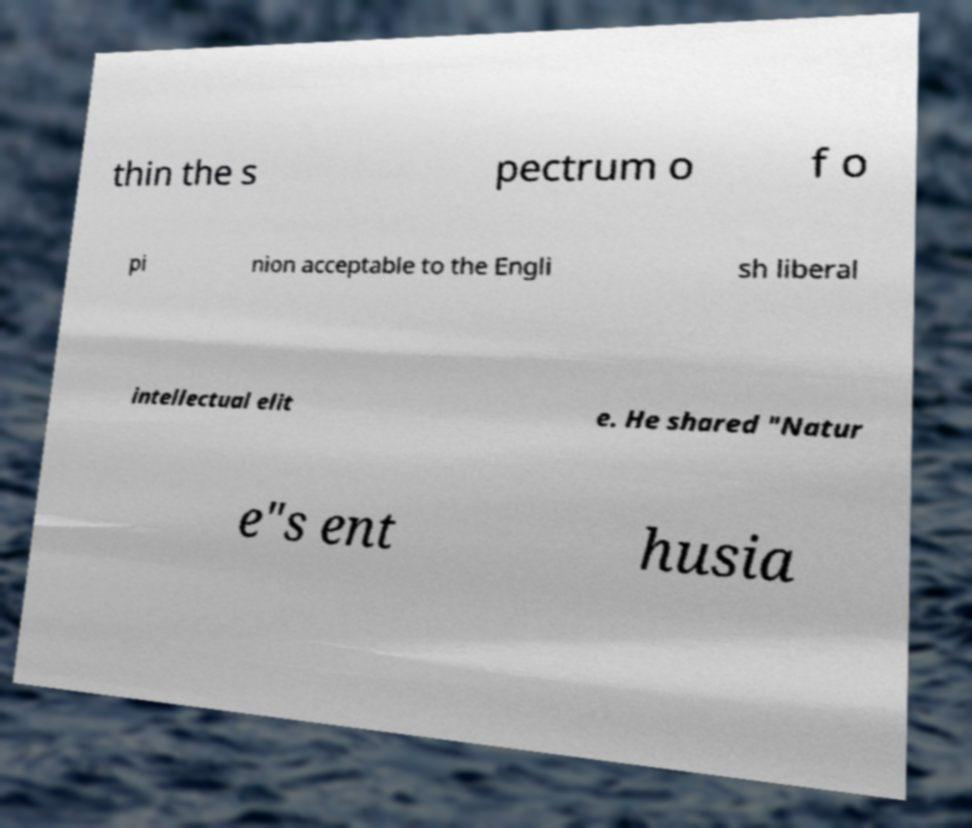Could you extract and type out the text from this image? thin the s pectrum o f o pi nion acceptable to the Engli sh liberal intellectual elit e. He shared "Natur e"s ent husia 